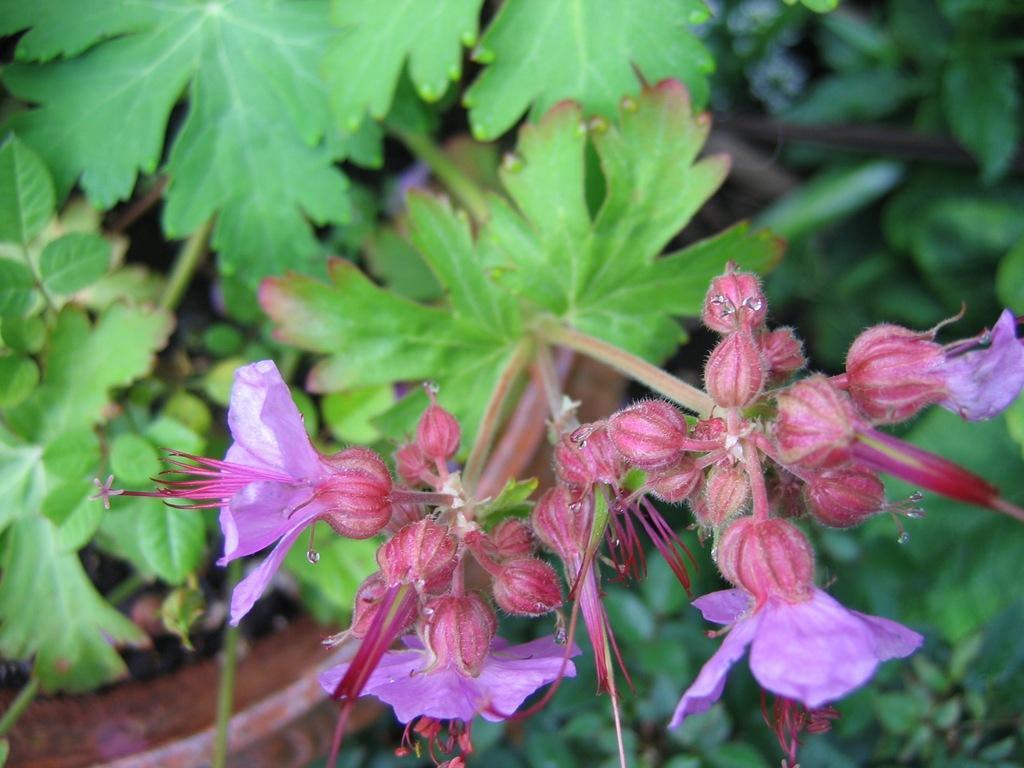In one or two sentences, can you explain what this image depicts? In the middle of the image there are some plants and flowers. 